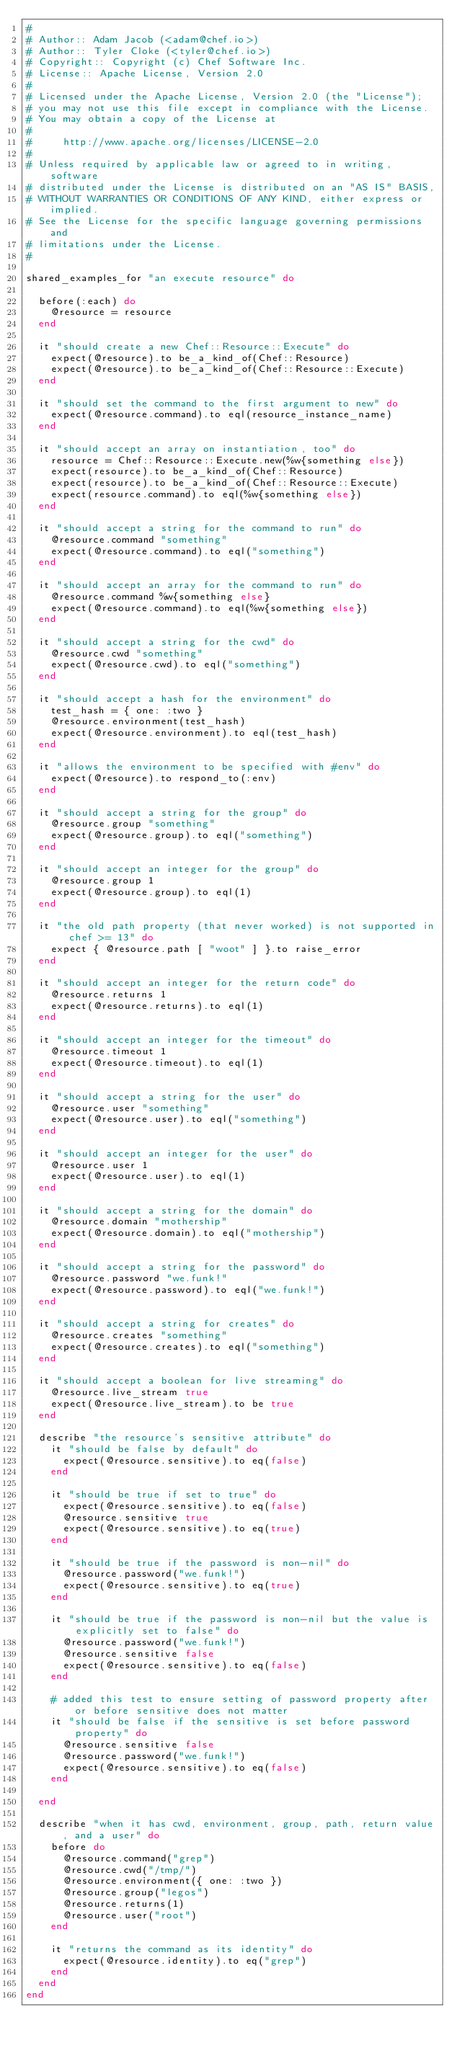<code> <loc_0><loc_0><loc_500><loc_500><_Ruby_>#
# Author:: Adam Jacob (<adam@chef.io>)
# Author:: Tyler Cloke (<tyler@chef.io>)
# Copyright:: Copyright (c) Chef Software Inc.
# License:: Apache License, Version 2.0
#
# Licensed under the Apache License, Version 2.0 (the "License");
# you may not use this file except in compliance with the License.
# You may obtain a copy of the License at
#
#     http://www.apache.org/licenses/LICENSE-2.0
#
# Unless required by applicable law or agreed to in writing, software
# distributed under the License is distributed on an "AS IS" BASIS,
# WITHOUT WARRANTIES OR CONDITIONS OF ANY KIND, either express or implied.
# See the License for the specific language governing permissions and
# limitations under the License.
#

shared_examples_for "an execute resource" do

  before(:each) do
    @resource = resource
  end

  it "should create a new Chef::Resource::Execute" do
    expect(@resource).to be_a_kind_of(Chef::Resource)
    expect(@resource).to be_a_kind_of(Chef::Resource::Execute)
  end

  it "should set the command to the first argument to new" do
    expect(@resource.command).to eql(resource_instance_name)
  end

  it "should accept an array on instantiation, too" do
    resource = Chef::Resource::Execute.new(%w{something else})
    expect(resource).to be_a_kind_of(Chef::Resource)
    expect(resource).to be_a_kind_of(Chef::Resource::Execute)
    expect(resource.command).to eql(%w{something else})
  end

  it "should accept a string for the command to run" do
    @resource.command "something"
    expect(@resource.command).to eql("something")
  end

  it "should accept an array for the command to run" do
    @resource.command %w{something else}
    expect(@resource.command).to eql(%w{something else})
  end

  it "should accept a string for the cwd" do
    @resource.cwd "something"
    expect(@resource.cwd).to eql("something")
  end

  it "should accept a hash for the environment" do
    test_hash = { one: :two }
    @resource.environment(test_hash)
    expect(@resource.environment).to eql(test_hash)
  end

  it "allows the environment to be specified with #env" do
    expect(@resource).to respond_to(:env)
  end

  it "should accept a string for the group" do
    @resource.group "something"
    expect(@resource.group).to eql("something")
  end

  it "should accept an integer for the group" do
    @resource.group 1
    expect(@resource.group).to eql(1)
  end

  it "the old path property (that never worked) is not supported in chef >= 13" do
    expect { @resource.path [ "woot" ] }.to raise_error
  end

  it "should accept an integer for the return code" do
    @resource.returns 1
    expect(@resource.returns).to eql(1)
  end

  it "should accept an integer for the timeout" do
    @resource.timeout 1
    expect(@resource.timeout).to eql(1)
  end

  it "should accept a string for the user" do
    @resource.user "something"
    expect(@resource.user).to eql("something")
  end

  it "should accept an integer for the user" do
    @resource.user 1
    expect(@resource.user).to eql(1)
  end

  it "should accept a string for the domain" do
    @resource.domain "mothership"
    expect(@resource.domain).to eql("mothership")
  end

  it "should accept a string for the password" do
    @resource.password "we.funk!"
    expect(@resource.password).to eql("we.funk!")
  end

  it "should accept a string for creates" do
    @resource.creates "something"
    expect(@resource.creates).to eql("something")
  end

  it "should accept a boolean for live streaming" do
    @resource.live_stream true
    expect(@resource.live_stream).to be true
  end

  describe "the resource's sensitive attribute" do
    it "should be false by default" do
      expect(@resource.sensitive).to eq(false)
    end

    it "should be true if set to true" do
      expect(@resource.sensitive).to eq(false)
      @resource.sensitive true
      expect(@resource.sensitive).to eq(true)
    end

    it "should be true if the password is non-nil" do
      @resource.password("we.funk!")
      expect(@resource.sensitive).to eq(true)
    end

    it "should be true if the password is non-nil but the value is explicitly set to false" do
      @resource.password("we.funk!")
      @resource.sensitive false
      expect(@resource.sensitive).to eq(false)
    end

    # added this test to ensure setting of password property after or before sensitive does not matter
    it "should be false if the sensitive is set before password property" do
      @resource.sensitive false
      @resource.password("we.funk!")
      expect(@resource.sensitive).to eq(false)
    end

  end

  describe "when it has cwd, environment, group, path, return value, and a user" do
    before do
      @resource.command("grep")
      @resource.cwd("/tmp/")
      @resource.environment({ one: :two })
      @resource.group("legos")
      @resource.returns(1)
      @resource.user("root")
    end

    it "returns the command as its identity" do
      expect(@resource.identity).to eq("grep")
    end
  end
end
</code> 